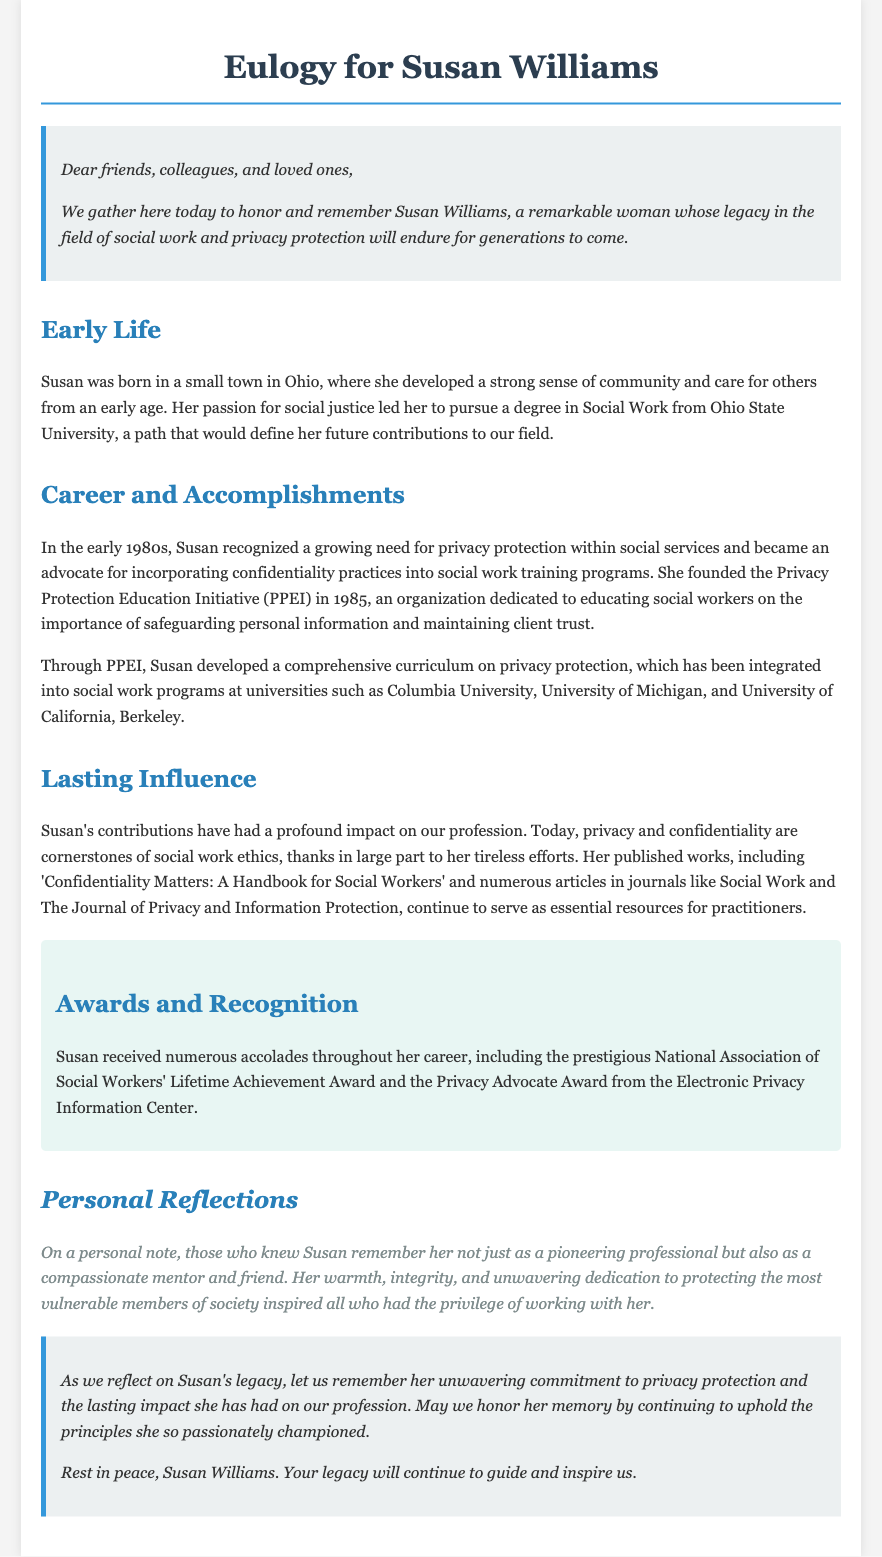What year was the Privacy Protection Education Initiative founded? The document states that the Privacy Protection Education Initiative (PPEI) was founded in 1985.
Answer: 1985 What is the title of Susan's published handbook? The document mentions that one of Susan's published works is titled "Confidentiality Matters: A Handbook for Social Workers."
Answer: Confidentiality Matters: A Handbook for Social Workers Which university is mentioned as having integrated Susan's curriculum? The document lists several universities, including Columbia University, as having integrated Susan's curriculum on privacy protection.
Answer: Columbia University What award did Susan receive for lifetime achievement? According to the document, Susan received the National Association of Social Workers' Lifetime Achievement Award.
Answer: National Association of Social Workers' Lifetime Achievement Award What was a central theme of Susan's work in social work? The document emphasizes that privacy and confidentiality are cornerstones of social work ethics, reflecting Susan's contributions.
Answer: Privacy and confidentiality Why is Susan's legacy particularly important for future social workers? The document suggests that Susan's tireless efforts led to the integration of privacy protection into social work training, highlighting its importance for future professionals.
Answer: Integration of privacy protection into training What description is given about Susan's mentoring style? The document describes Susan as not just a pioneering professional but also as a compassionate mentor and friend.
Answer: Compassionate mentor and friend What is the significance of the eulogy's conclusion? The conclusion emphasizes honoring Susan's memory by continuing to uphold the principles she championed, reinforcing her legacy.
Answer: Uphold principles she championed 